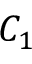Convert formula to latex. <formula><loc_0><loc_0><loc_500><loc_500>C _ { 1 }</formula> 